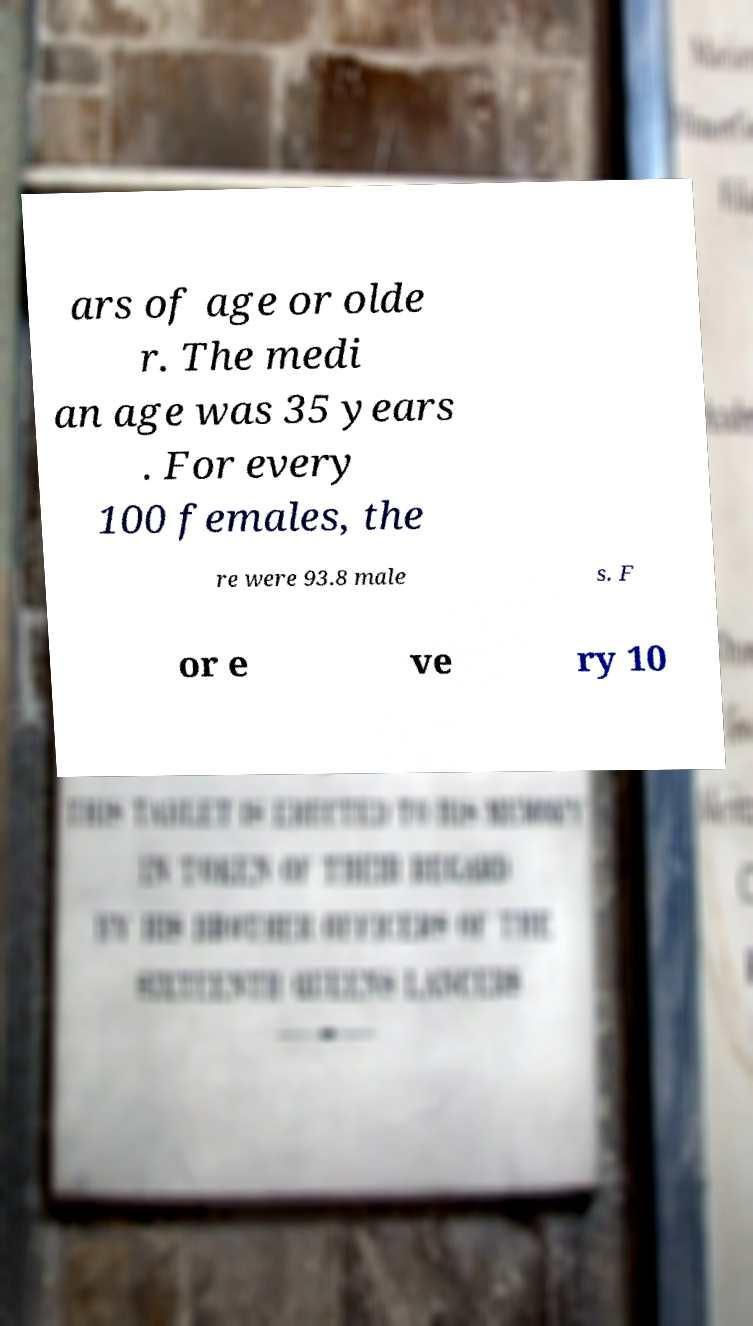What messages or text are displayed in this image? I need them in a readable, typed format. ars of age or olde r. The medi an age was 35 years . For every 100 females, the re were 93.8 male s. F or e ve ry 10 